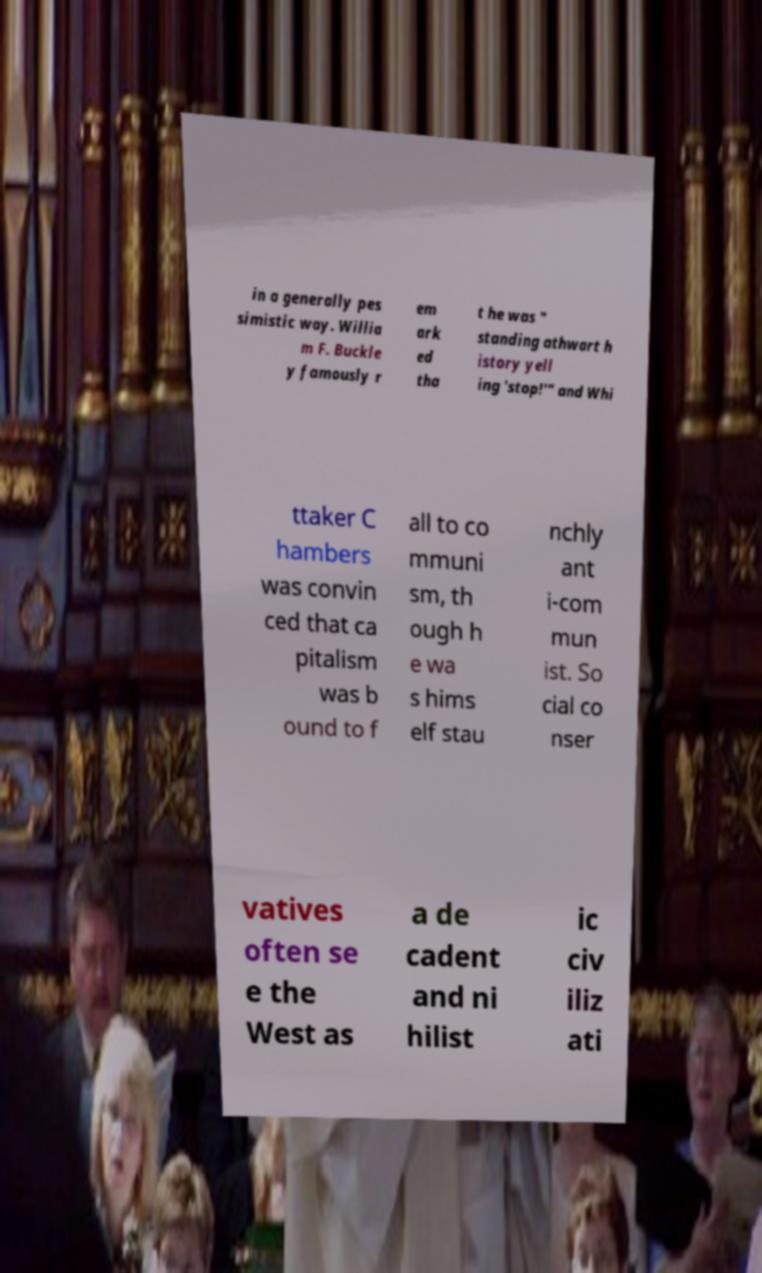Please read and relay the text visible in this image. What does it say? in a generally pes simistic way. Willia m F. Buckle y famously r em ark ed tha t he was " standing athwart h istory yell ing 'stop!'" and Whi ttaker C hambers was convin ced that ca pitalism was b ound to f all to co mmuni sm, th ough h e wa s hims elf stau nchly ant i-com mun ist. So cial co nser vatives often se e the West as a de cadent and ni hilist ic civ iliz ati 